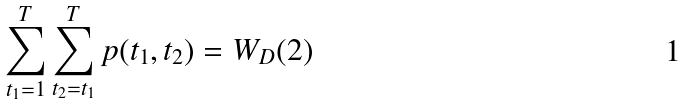Convert formula to latex. <formula><loc_0><loc_0><loc_500><loc_500>\sum _ { t _ { 1 } = 1 } ^ { T } \sum _ { t _ { 2 } = t _ { 1 } } ^ { T } p ( t _ { 1 } , t _ { 2 } ) = W _ { D } ( 2 )</formula> 